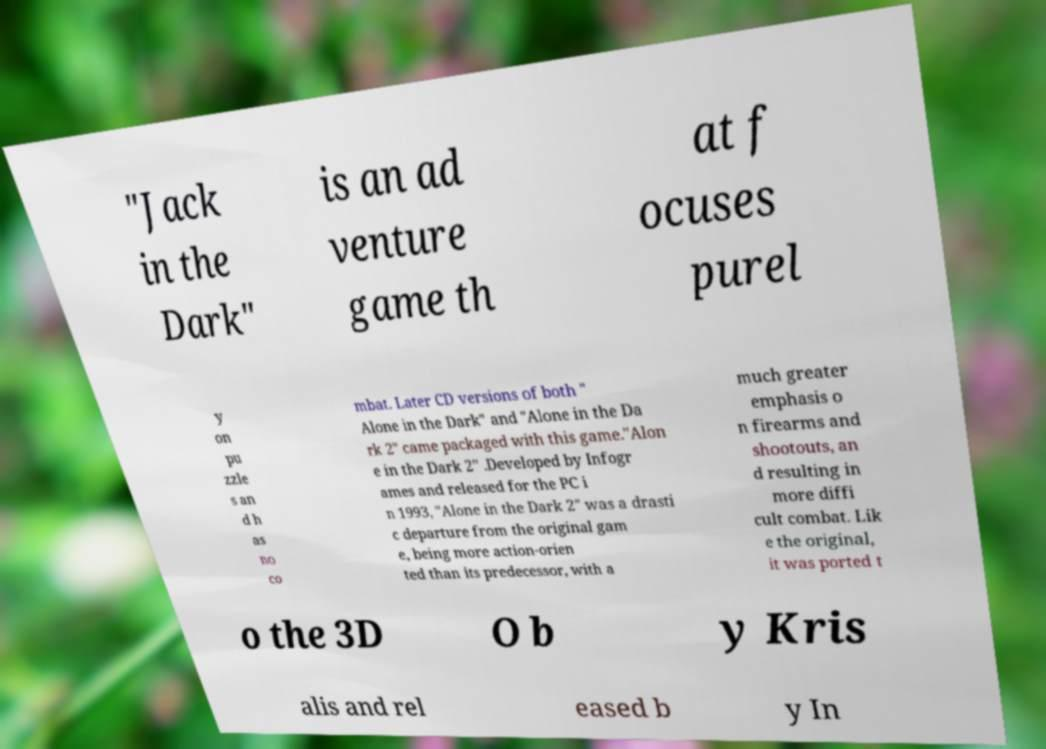For documentation purposes, I need the text within this image transcribed. Could you provide that? "Jack in the Dark" is an ad venture game th at f ocuses purel y on pu zzle s an d h as no co mbat. Later CD versions of both " Alone in the Dark" and "Alone in the Da rk 2" came packaged with this game."Alon e in the Dark 2" .Developed by Infogr ames and released for the PC i n 1993, "Alone in the Dark 2" was a drasti c departure from the original gam e, being more action-orien ted than its predecessor, with a much greater emphasis o n firearms and shootouts, an d resulting in more diffi cult combat. Lik e the original, it was ported t o the 3D O b y Kris alis and rel eased b y In 